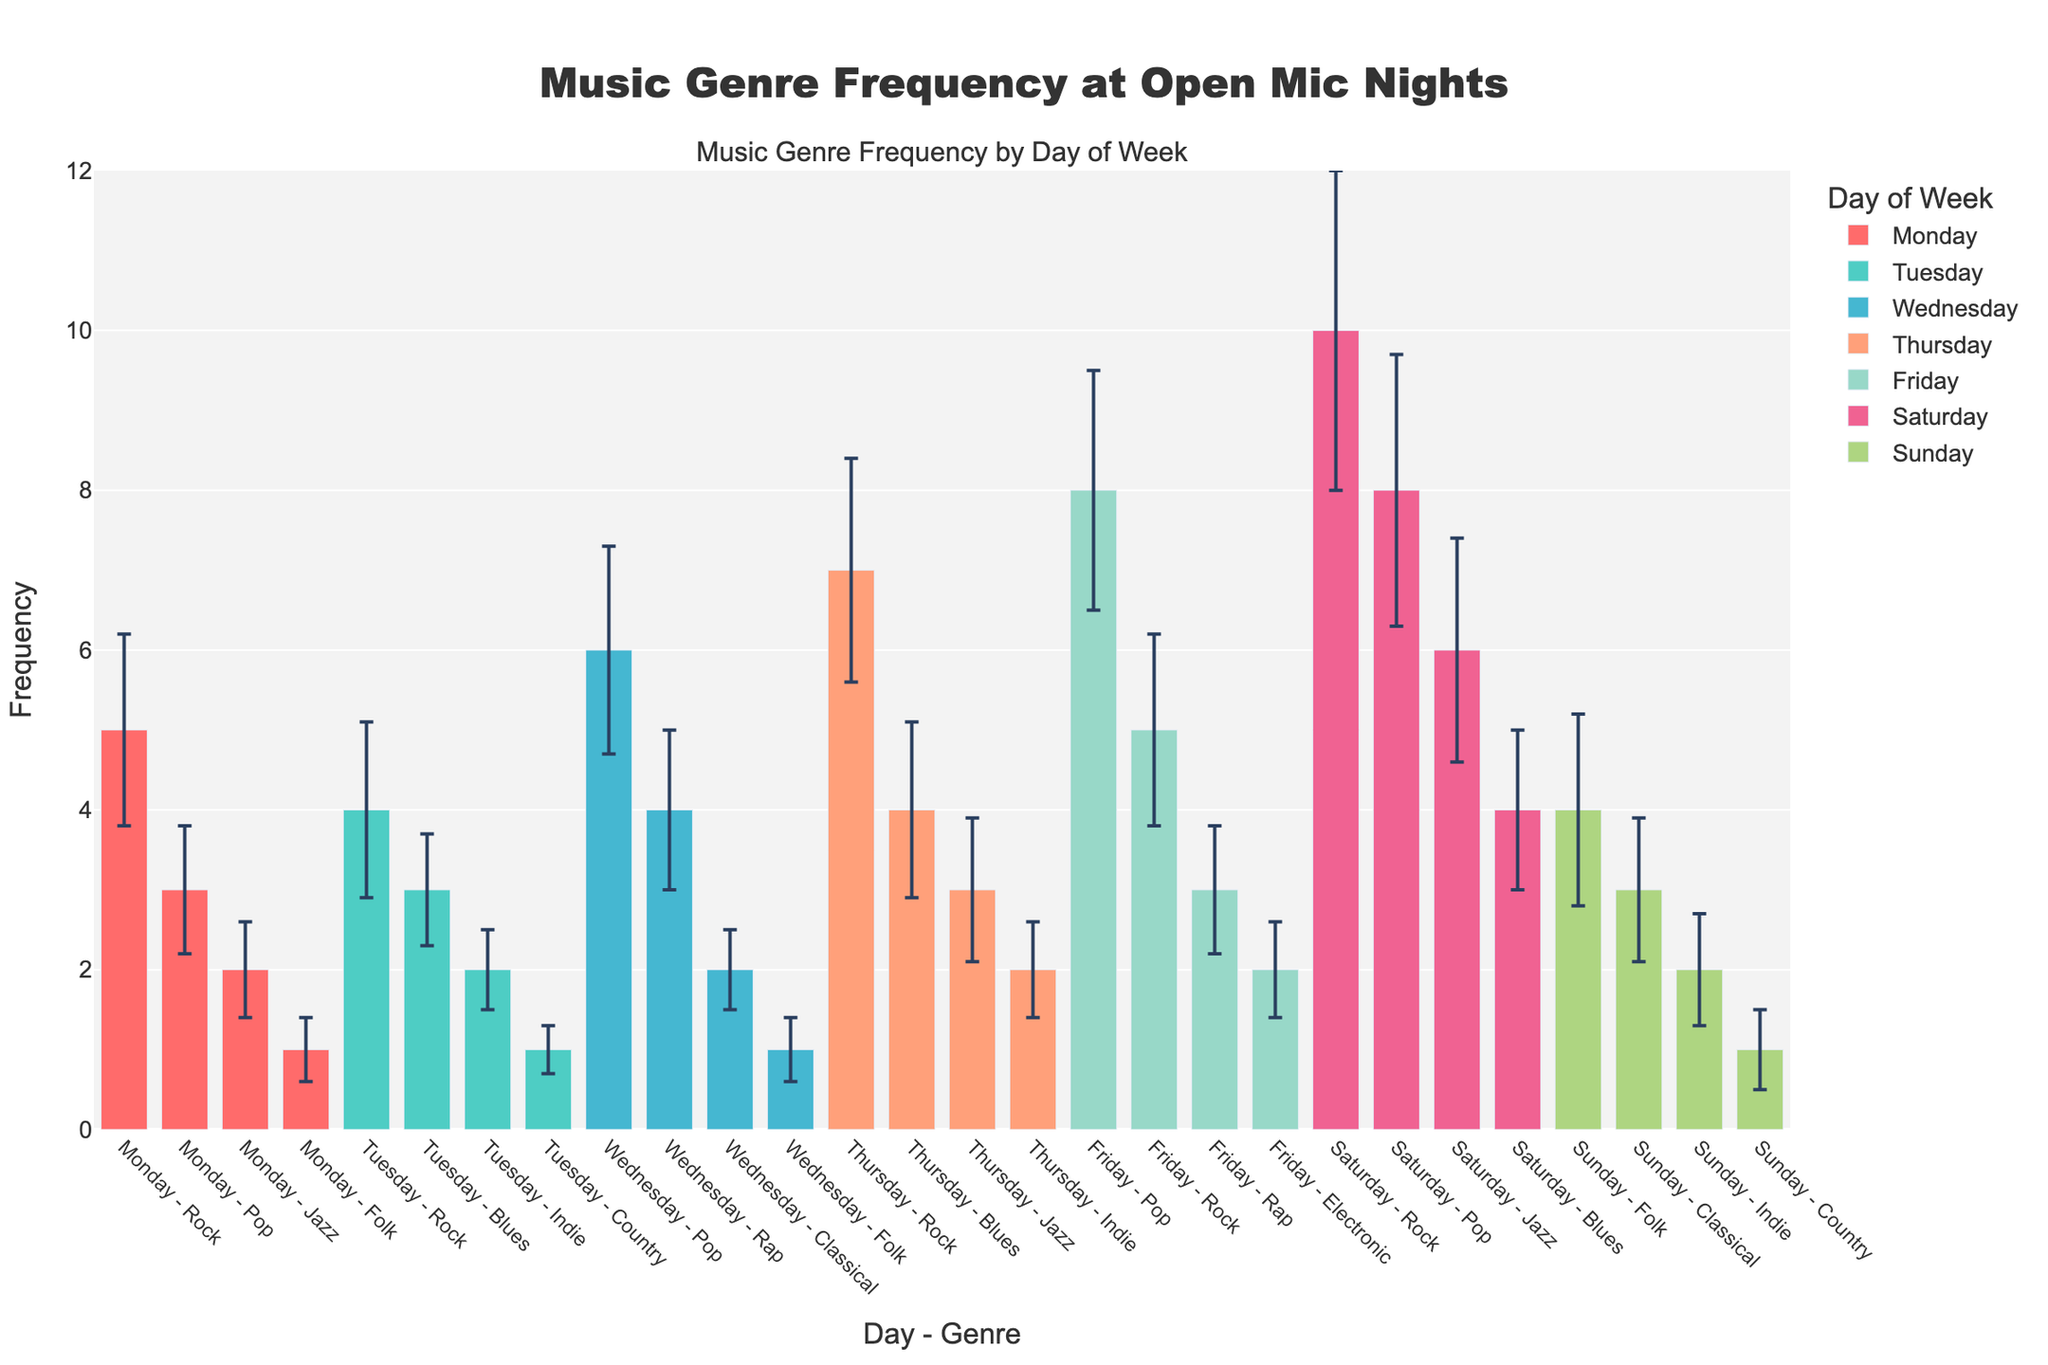what is the most frequently performed genre on Thursday? The most frequently performed genre on Thursday can be identified by looking at the bar corresponding to Thursday and comparing the heights. The Rock genre has the highest frequency of 7.
Answer: Rock What’s the average frequency of the Rock genre across all days? To find the average frequency of the Rock genre, sum the frequencies of Rock on all days (5+4+7+5+10) and divide by the number of days (5). The sum is 31, and 31/5 = 6.2.
Answer: 6.2 Which day has the highest total frequency of performances across all genres? Sum the frequencies of all genres for each day and compare. For Monday: 5+3+2+1 = 11, Tuesday: 4+3+2+1 = 10, Wednesday: 6+4+2+1 = 13, Thursday: 7+4+3+2 = 16, Friday: 8+5+3+2 = 18, Saturday: 10+8+6+4 = 28, Sunday: 4+3+2+1 = 10. Saturday has the highest total frequency of 28.
Answer: Saturday Which genre has the highest error bars on average across all days? Calculate the average standard deviation for each genre. For Rock: (1.2+1.1+1.4+1.2+2.0)/5=1.38, for Pop: (0.8+1.3+1.5+1.7)/4=1.325, etc. Jazz, Indie, Electronic have Std Dev averages as well. The highest average std deviation is for Rock: 1.38.
Answer: Rock What's the frequency range for the genre "Pop" across all days? The frequency range can be found by subtracting the minimum frequency of Pop from the maximum frequency of Pop. The maximum frequency is 8 on Friday and Saturday, and the minimum is 3 on Monday. Therefore, 8-3 = 5.
Answer: 5 How does the performance frequency of "Jazz" compare to "Blues" on Saturday? By inspecting the bars for Jazz and Blues on Saturday, we see that Jazz has a frequency of 6, while Blues has a frequency of 4. Jazz is performed more frequently than Blues on Saturday.
Answer: Jazz more than Blues What is the least frequently performed genre on Tuesday? By looking at Tuesday's bars, the least frequently performed genre is Country with a frequency of 1.
Answer: Country How many genres are performed only once throughout the week? Count the bars with a frequency of 1 across all days. They are Folk on Monday, Country on Tuesday, Folk on Wednesday, Country on Sunday. There are 4 genres meeting the criteria.
Answer: 4 